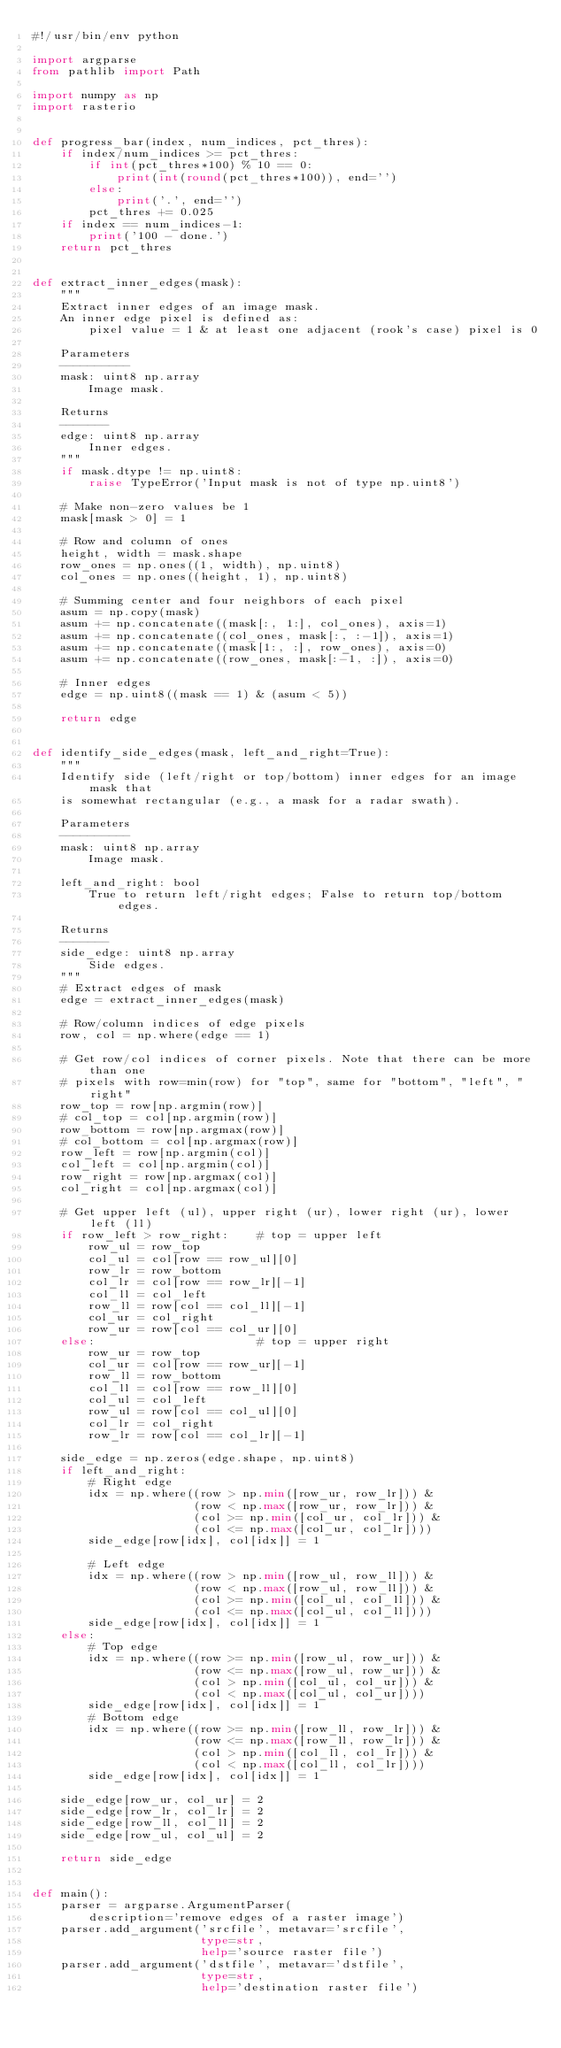Convert code to text. <code><loc_0><loc_0><loc_500><loc_500><_Python_>#!/usr/bin/env python

import argparse
from pathlib import Path

import numpy as np
import rasterio


def progress_bar(index, num_indices, pct_thres):
    if index/num_indices >= pct_thres:
        if int(pct_thres*100) % 10 == 0:
            print(int(round(pct_thres*100)), end='')
        else:
            print('.', end='')
        pct_thres += 0.025
    if index == num_indices-1:
        print('100 - done.')
    return pct_thres


def extract_inner_edges(mask):
    """
    Extract inner edges of an image mask.
    An inner edge pixel is defined as:
        pixel value = 1 & at least one adjacent (rook's case) pixel is 0

    Parameters
    ----------
    mask: uint8 np.array
        Image mask.

    Returns
    -------
    edge: uint8 np.array
        Inner edges.
    """
    if mask.dtype != np.uint8:
        raise TypeError('Input mask is not of type np.uint8')

    # Make non-zero values be 1
    mask[mask > 0] = 1

    # Row and column of ones
    height, width = mask.shape
    row_ones = np.ones((1, width), np.uint8)
    col_ones = np.ones((height, 1), np.uint8)

    # Summing center and four neighbors of each pixel
    asum = np.copy(mask)
    asum += np.concatenate((mask[:, 1:], col_ones), axis=1)
    asum += np.concatenate((col_ones, mask[:, :-1]), axis=1)
    asum += np.concatenate((mask[1:, :], row_ones), axis=0)
    asum += np.concatenate((row_ones, mask[:-1, :]), axis=0)

    # Inner edges
    edge = np.uint8((mask == 1) & (asum < 5))

    return edge


def identify_side_edges(mask, left_and_right=True):
    """
    Identify side (left/right or top/bottom) inner edges for an image mask that
    is somewhat rectangular (e.g., a mask for a radar swath).

    Parameters
    ----------
    mask: uint8 np.array
        Image mask.

    left_and_right: bool
        True to return left/right edges; False to return top/bottom edges.

    Returns
    -------
    side_edge: uint8 np.array
        Side edges.
    """
    # Extract edges of mask
    edge = extract_inner_edges(mask)

    # Row/column indices of edge pixels
    row, col = np.where(edge == 1)

    # Get row/col indices of corner pixels. Note that there can be more than one
    # pixels with row=min(row) for "top", same for "bottom", "left", "right"
    row_top = row[np.argmin(row)]
    # col_top = col[np.argmin(row)]
    row_bottom = row[np.argmax(row)]
    # col_bottom = col[np.argmax(row)]
    row_left = row[np.argmin(col)]
    col_left = col[np.argmin(col)]
    row_right = row[np.argmax(col)]
    col_right = col[np.argmax(col)]

    # Get upper left (ul), upper right (ur), lower right (ur), lower left (ll)
    if row_left > row_right:    # top = upper left
        row_ul = row_top
        col_ul = col[row == row_ul][0]
        row_lr = row_bottom
        col_lr = col[row == row_lr][-1]
        col_ll = col_left
        row_ll = row[col == col_ll][-1]
        col_ur = col_right
        row_ur = row[col == col_ur][0]
    else:                       # top = upper right
        row_ur = row_top
        col_ur = col[row == row_ur][-1]
        row_ll = row_bottom
        col_ll = col[row == row_ll][0]
        col_ul = col_left
        row_ul = row[col == col_ul][0]
        col_lr = col_right
        row_lr = row[col == col_lr][-1]

    side_edge = np.zeros(edge.shape, np.uint8)
    if left_and_right:
        # Right edge
        idx = np.where((row > np.min([row_ur, row_lr])) &
                       (row < np.max([row_ur, row_lr])) &
                       (col >= np.min([col_ur, col_lr])) &
                       (col <= np.max([col_ur, col_lr])))
        side_edge[row[idx], col[idx]] = 1

        # Left edge
        idx = np.where((row > np.min([row_ul, row_ll])) &
                       (row < np.max([row_ul, row_ll])) &
                       (col >= np.min([col_ul, col_ll])) &
                       (col <= np.max([col_ul, col_ll])))
        side_edge[row[idx], col[idx]] = 1
    else:
        # Top edge
        idx = np.where((row >= np.min([row_ul, row_ur])) &
                       (row <= np.max([row_ul, row_ur])) &
                       (col > np.min([col_ul, col_ur])) &
                       (col < np.max([col_ul, col_ur])))
        side_edge[row[idx], col[idx]] = 1
        # Bottom edge
        idx = np.where((row >= np.min([row_ll, row_lr])) &
                       (row <= np.max([row_ll, row_lr])) &
                       (col > np.min([col_ll, col_lr])) &
                       (col < np.max([col_ll, col_lr])))
        side_edge[row[idx], col[idx]] = 1

    side_edge[row_ur, col_ur] = 2
    side_edge[row_lr, col_lr] = 2
    side_edge[row_ll, col_ll] = 2
    side_edge[row_ul, col_ul] = 2

    return side_edge


def main():
    parser = argparse.ArgumentParser(
        description='remove edges of a raster image')
    parser.add_argument('srcfile', metavar='srcfile',
                        type=str,
                        help='source raster file')
    parser.add_argument('dstfile', metavar='dstfile',
                        type=str,
                        help='destination raster file')</code> 